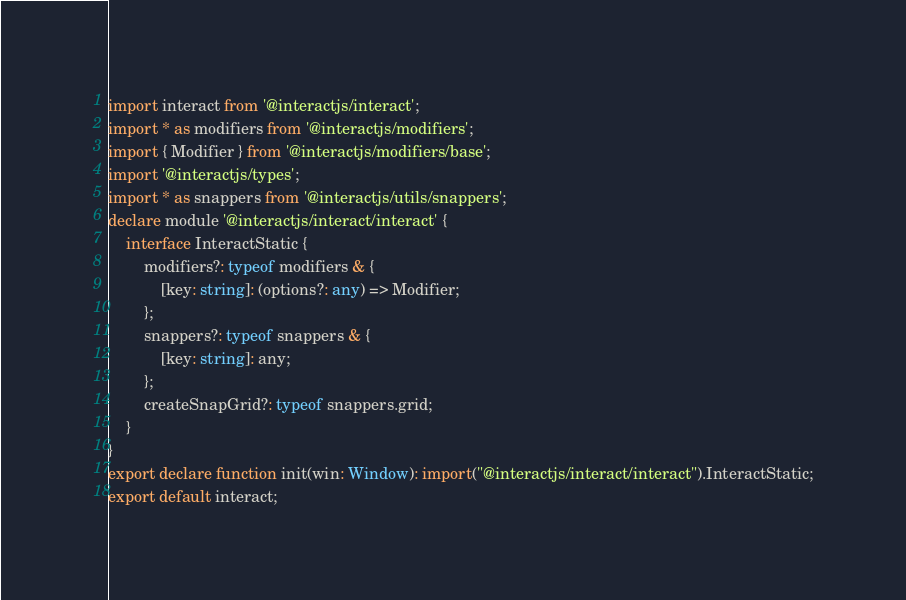Convert code to text. <code><loc_0><loc_0><loc_500><loc_500><_TypeScript_>import interact from '@interactjs/interact';
import * as modifiers from '@interactjs/modifiers';
import { Modifier } from '@interactjs/modifiers/base';
import '@interactjs/types';
import * as snappers from '@interactjs/utils/snappers';
declare module '@interactjs/interact/interact' {
    interface InteractStatic {
        modifiers?: typeof modifiers & {
            [key: string]: (options?: any) => Modifier;
        };
        snappers?: typeof snappers & {
            [key: string]: any;
        };
        createSnapGrid?: typeof snappers.grid;
    }
}
export declare function init(win: Window): import("@interactjs/interact/interact").InteractStatic;
export default interact;
</code> 